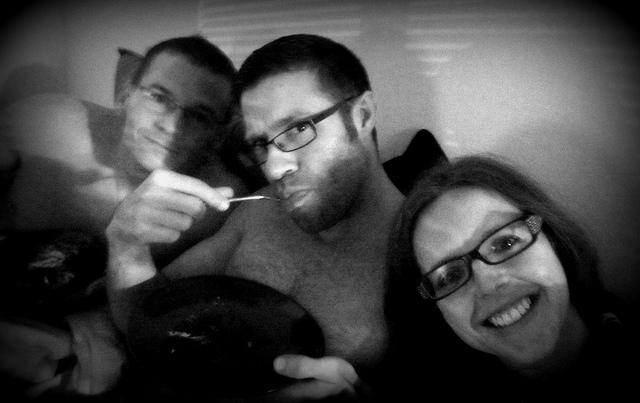What is a good word to describe all of these people? happy 